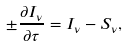<formula> <loc_0><loc_0><loc_500><loc_500>\pm \frac { \partial { I _ { \nu } } } { \partial { \tau } } = I _ { \nu } - S _ { \nu } ,</formula> 